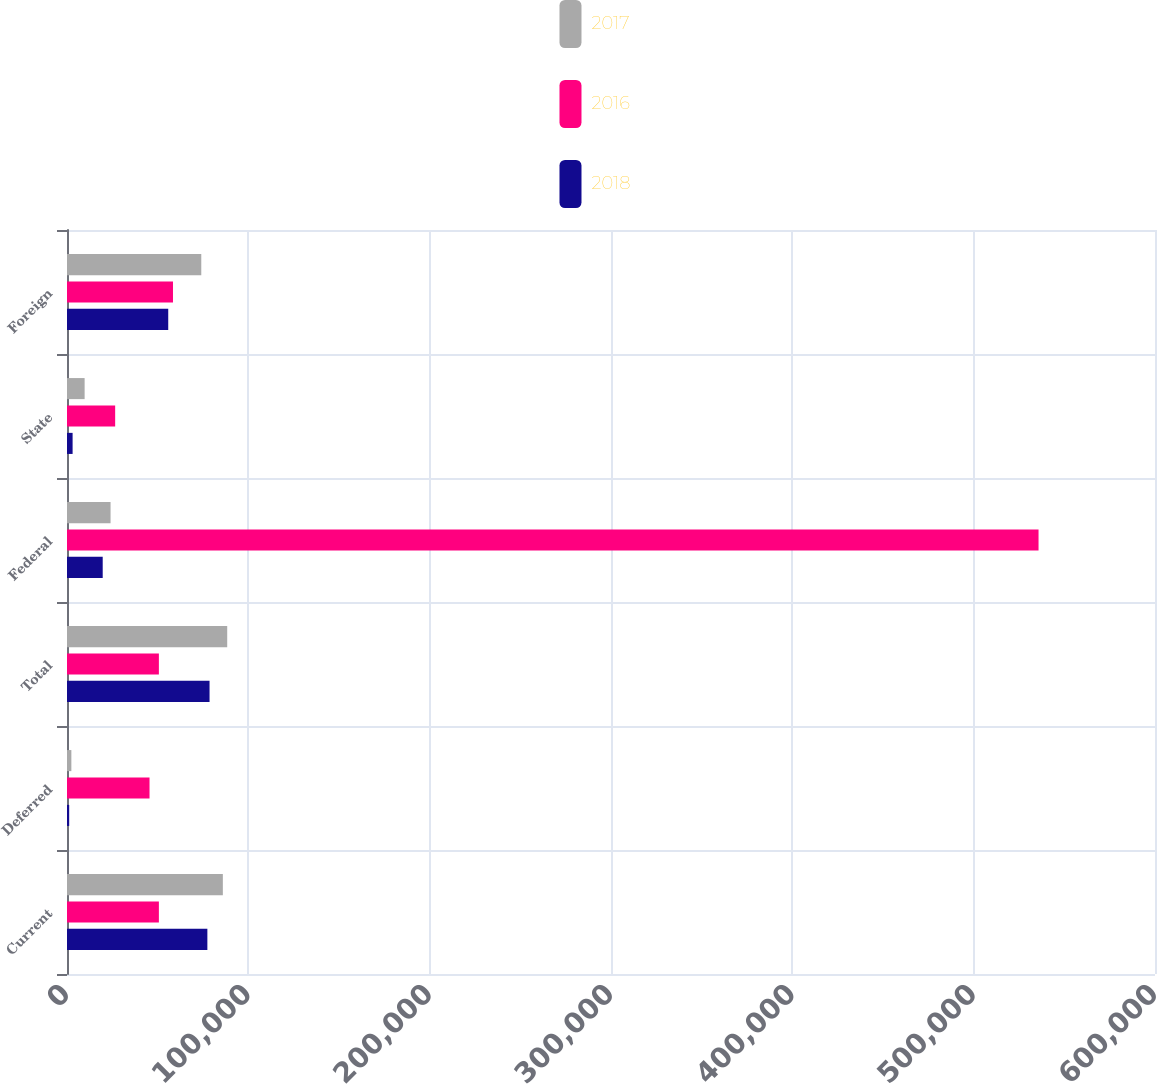<chart> <loc_0><loc_0><loc_500><loc_500><stacked_bar_chart><ecel><fcel>Current<fcel>Deferred<fcel>Total<fcel>Federal<fcel>State<fcel>Foreign<nl><fcel>2017<fcel>85947<fcel>2405<fcel>88352<fcel>24021<fcel>9717<fcel>74048<nl><fcel>2016<fcel>50669<fcel>45510<fcel>50669<fcel>535777<fcel>26561<fcel>58448<nl><fcel>2018<fcel>77407<fcel>1204<fcel>78611<fcel>19693<fcel>3090<fcel>55828<nl></chart> 